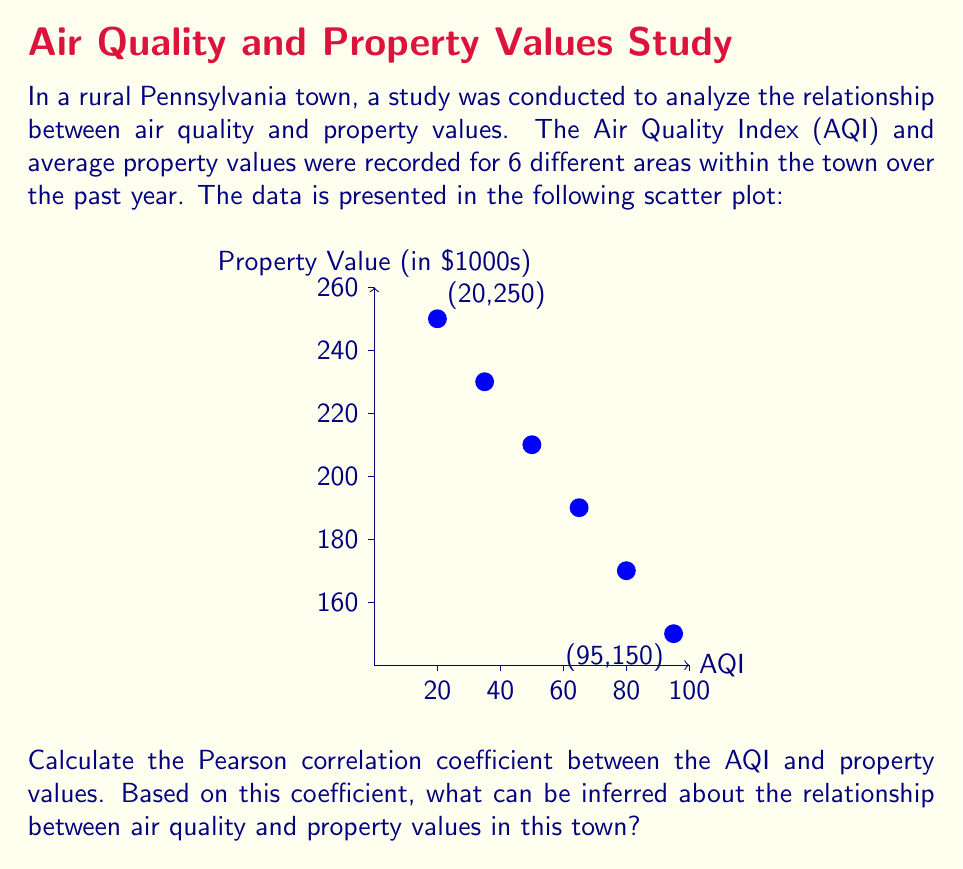Can you solve this math problem? To calculate the Pearson correlation coefficient, we'll follow these steps:

1) First, let's organize our data:
   x (AQI): 20, 35, 50, 65, 80, 95
   y (Property Value in $1000s): 250, 230, 210, 190, 170, 150

2) Calculate the means:
   $\bar{x} = \frac{20 + 35 + 50 + 65 + 80 + 95}{6} = 57.5$
   $\bar{y} = \frac{250 + 230 + 210 + 190 + 170 + 150}{6} = 200$

3) Calculate the sum of squares:
   $\sum (x - \bar{x})^2 = 5512.5$
   $\sum (y - \bar{y})^2 = 5000$
   $\sum (x - \bar{x})(y - \bar{y}) = -5250$

4) Apply the Pearson correlation coefficient formula:
   $$r = \frac{\sum (x - \bar{x})(y - \bar{y})}{\sqrt{\sum (x - \bar{x})^2 \sum (y - \bar{y})^2}}$$

   $$r = \frac{-5250}{\sqrt{5512.5 \times 5000}} = -0.9988$$

5) Interpret the result:
   The correlation coefficient of -0.9988 indicates a very strong negative correlation between AQI and property values. As AQI increases (indicating poorer air quality), property values decrease almost perfectly linearly.

This strong negative correlation suggests that air quality has a significant impact on property values in this rural Pennsylvania town. Areas with better air quality (lower AQI) tend to have higher property values, while areas with poorer air quality (higher AQI) have lower property values.
Answer: $r = -0.9988$; Very strong negative correlation between AQI and property values. 